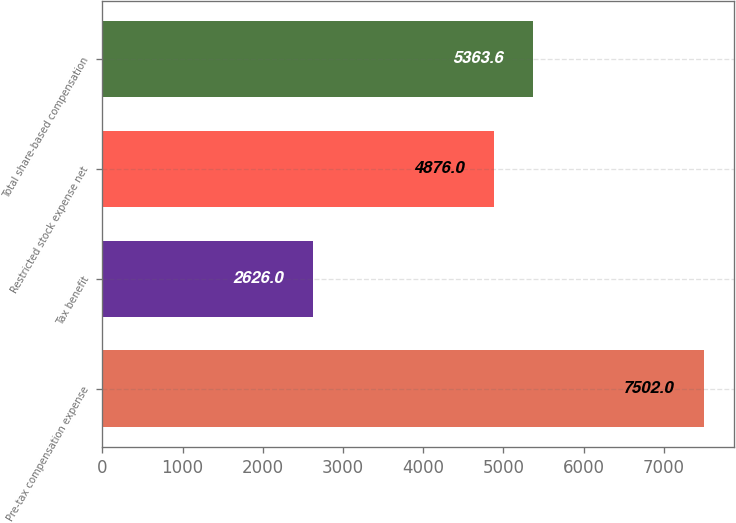Convert chart. <chart><loc_0><loc_0><loc_500><loc_500><bar_chart><fcel>Pre-tax compensation expense<fcel>Tax benefit<fcel>Restricted stock expense net<fcel>Total share-based compensation<nl><fcel>7502<fcel>2626<fcel>4876<fcel>5363.6<nl></chart> 